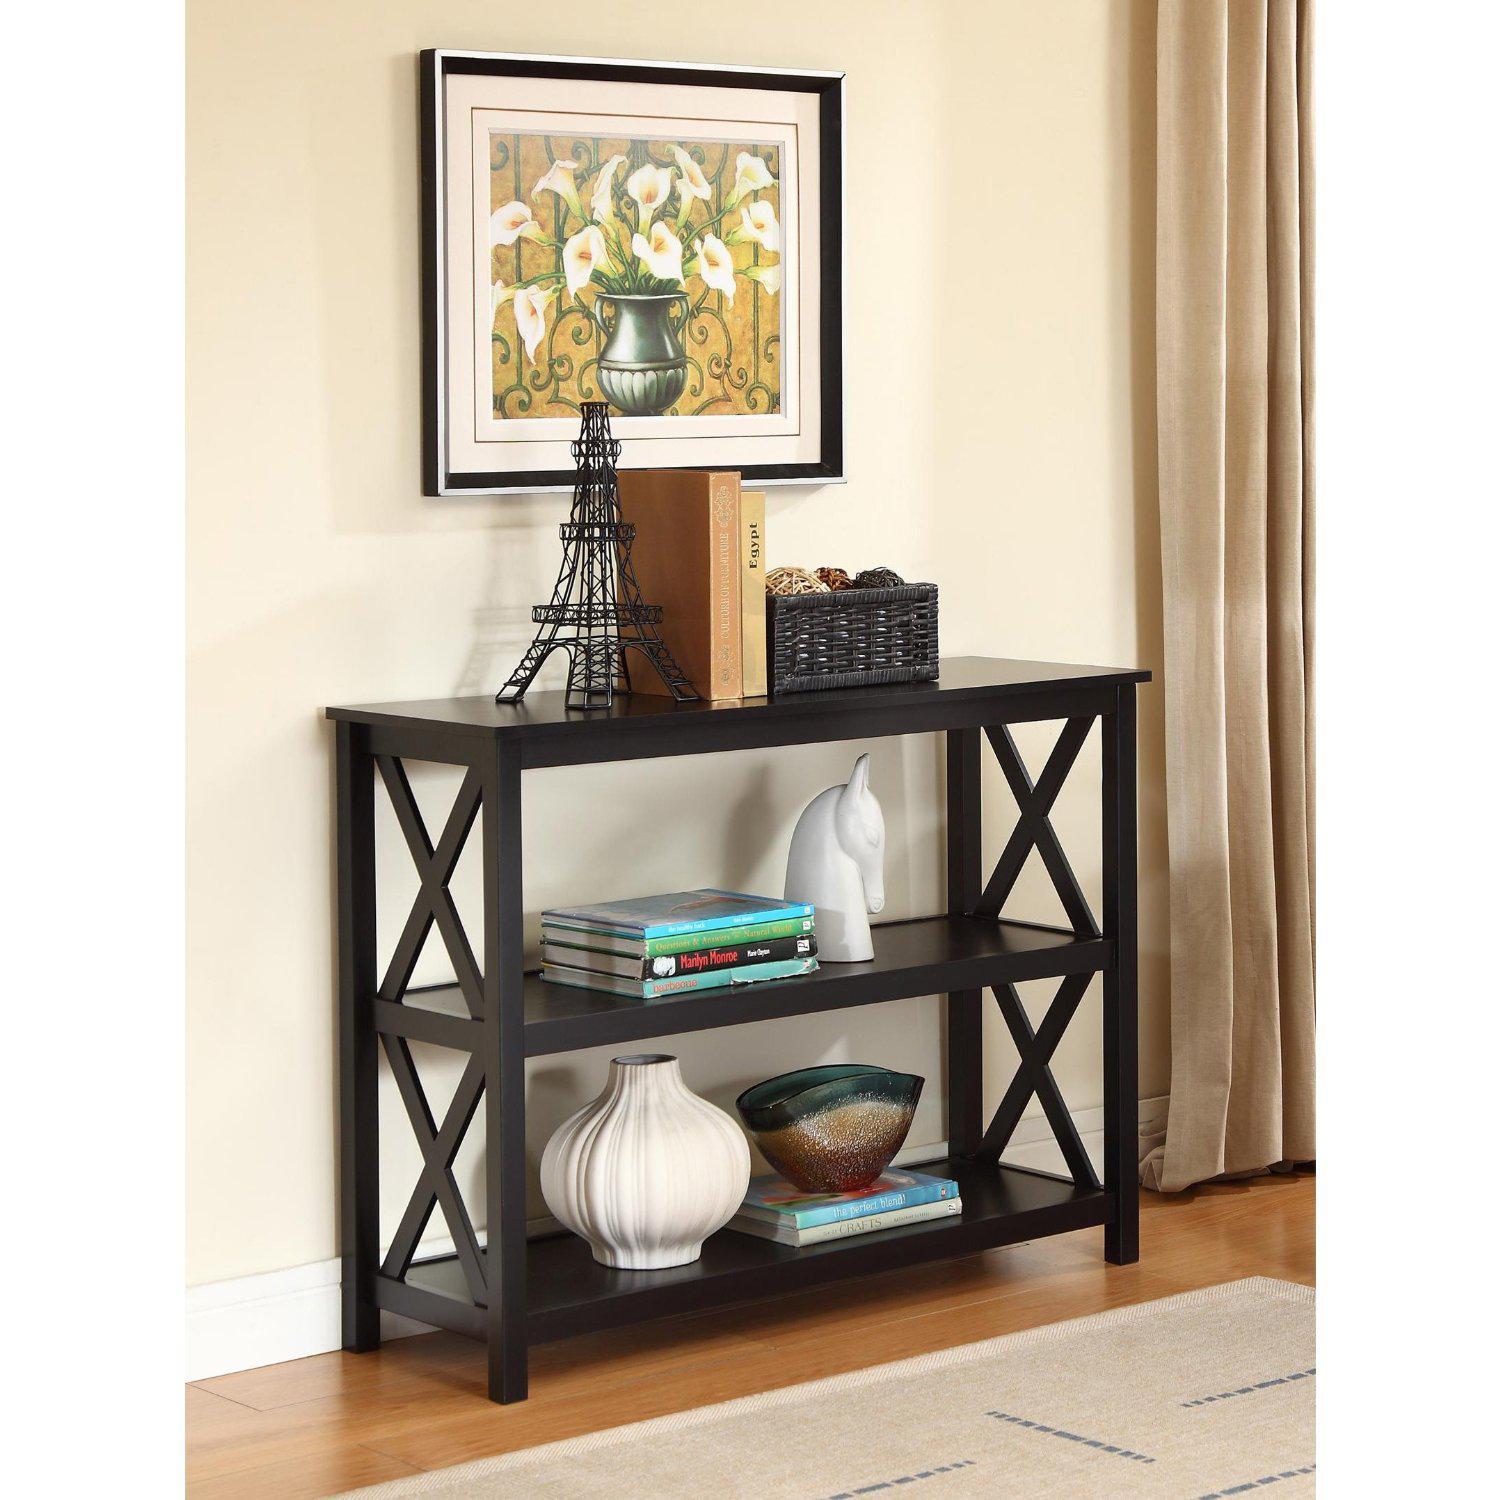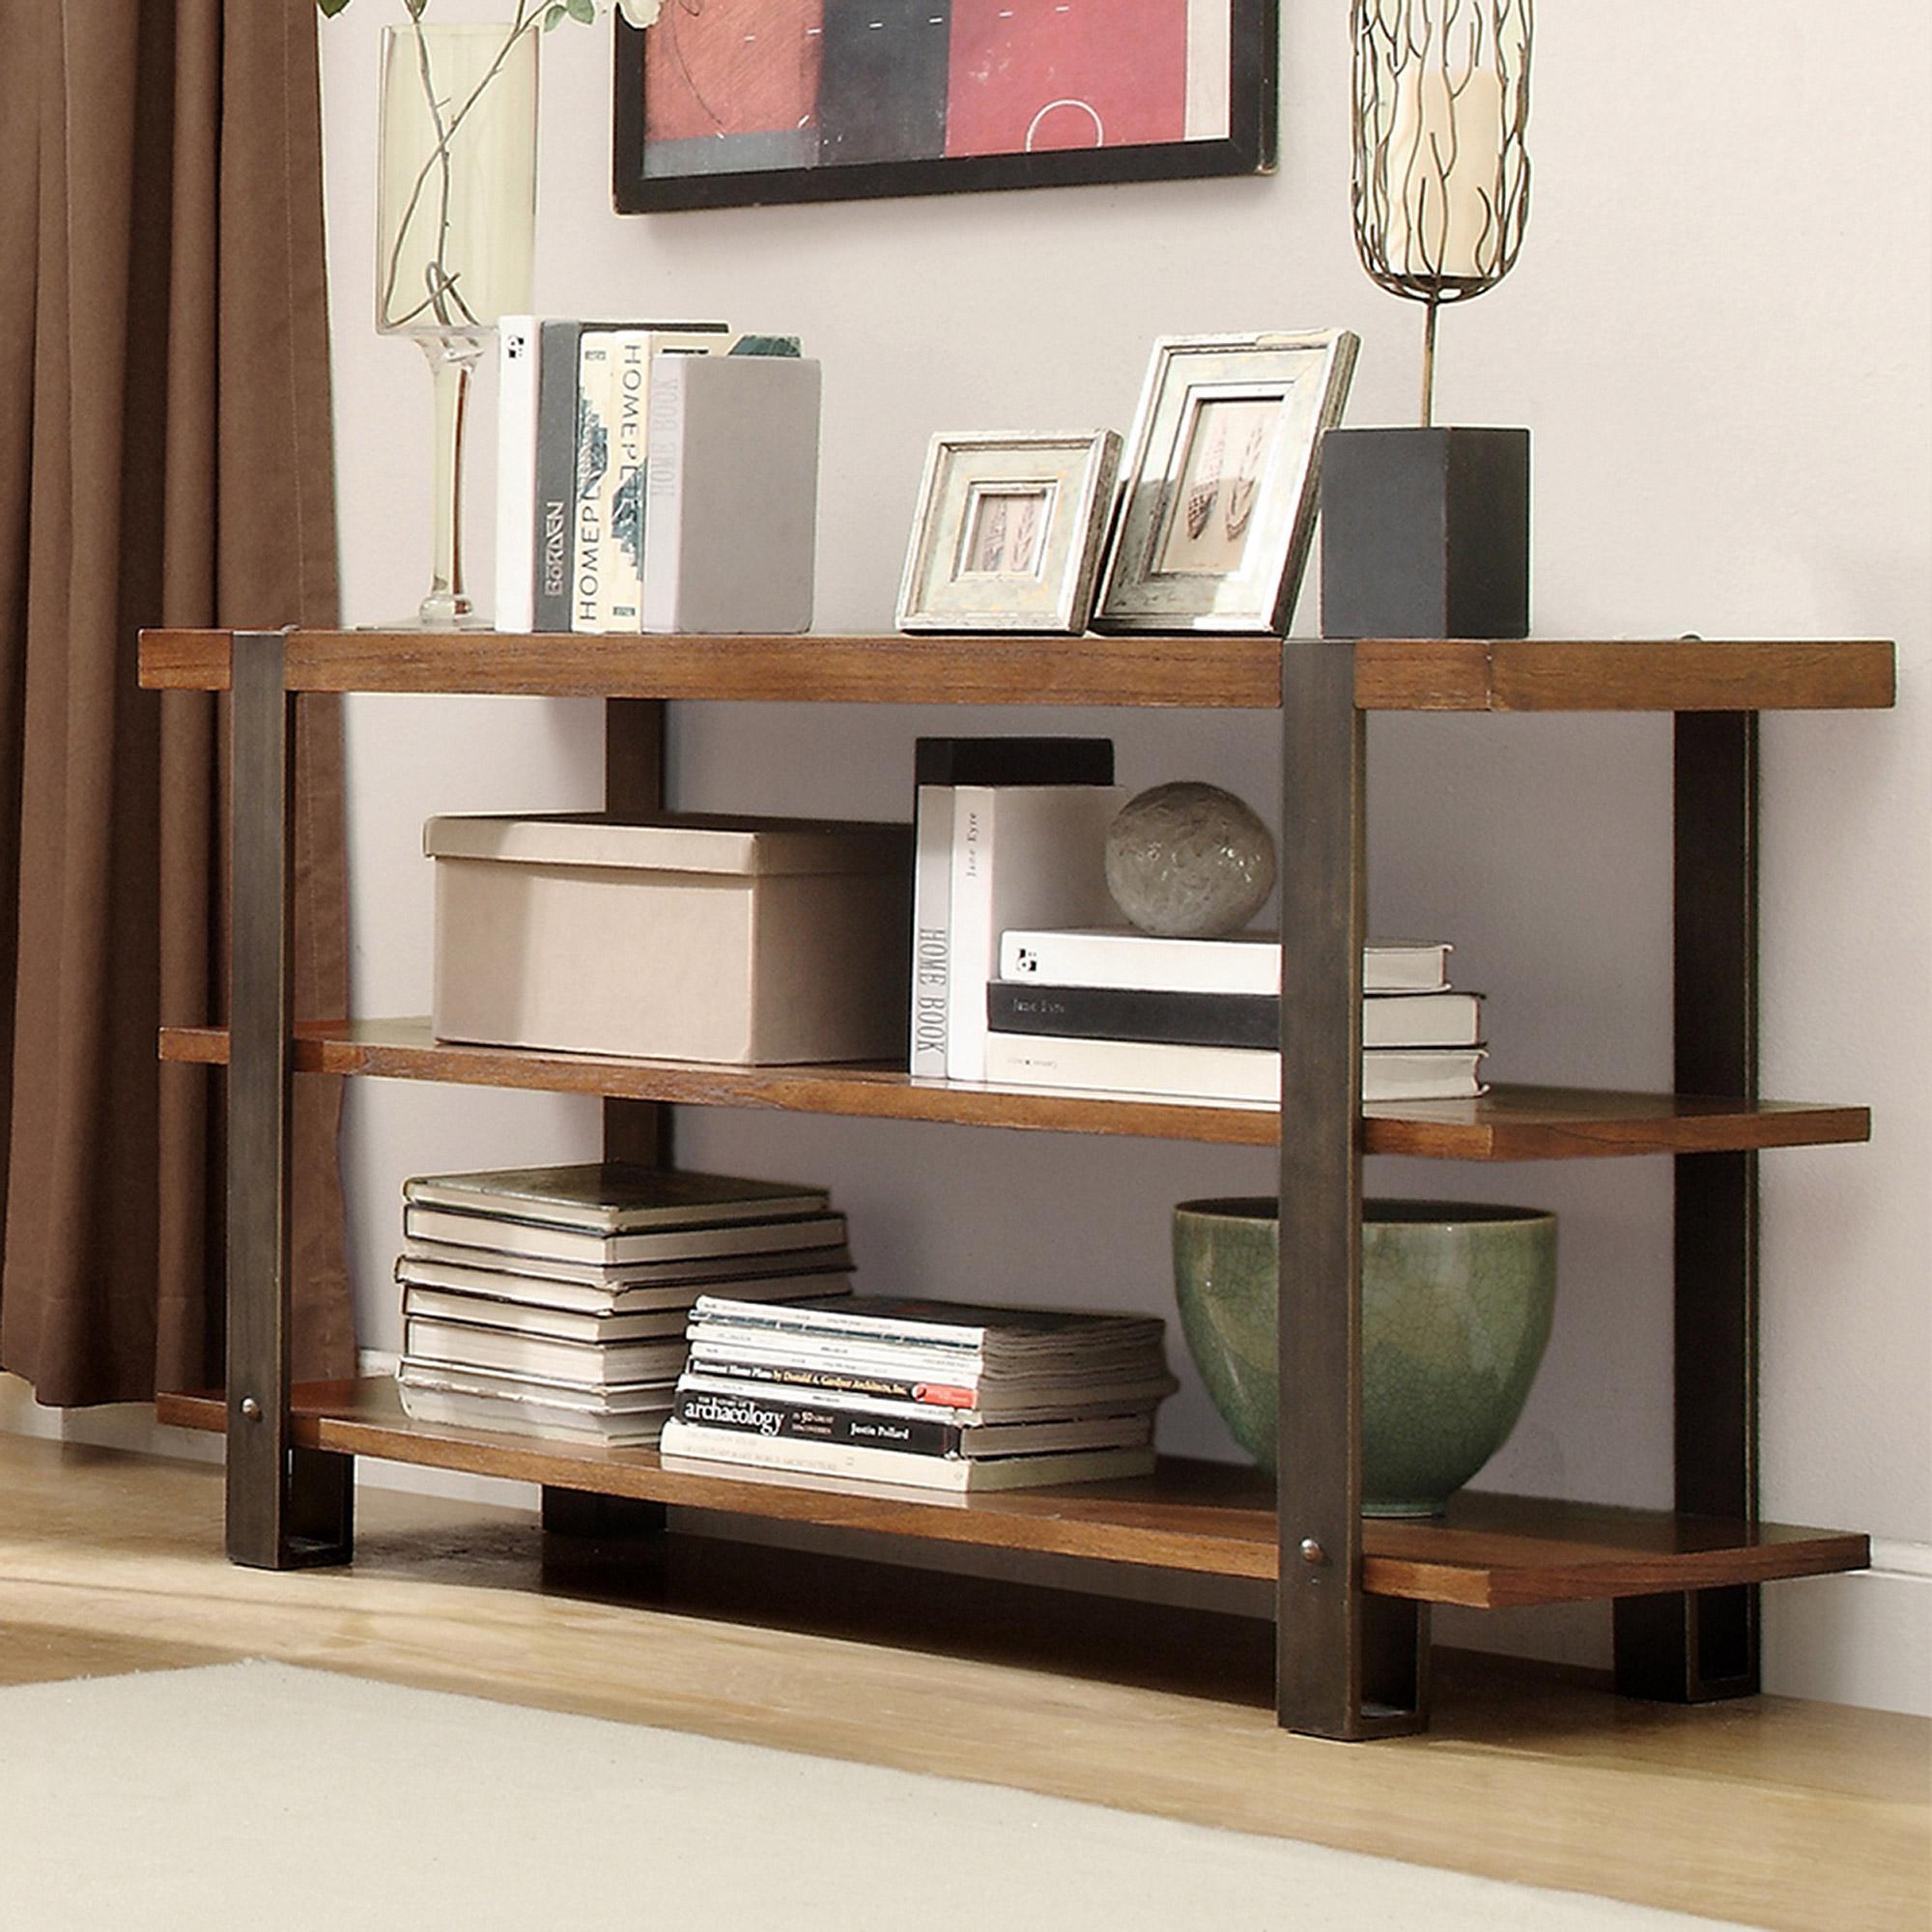The first image is the image on the left, the second image is the image on the right. Analyze the images presented: Is the assertion "there is a white built in bookshelf with a sofa , two chairs and a coffee table in front of it" valid? Answer yes or no. No. The first image is the image on the left, the second image is the image on the right. Examine the images to the left and right. Is the description "A gooseneck lamp is in front of a large paned window in a room with a sofa and coffee table." accurate? Answer yes or no. No. 